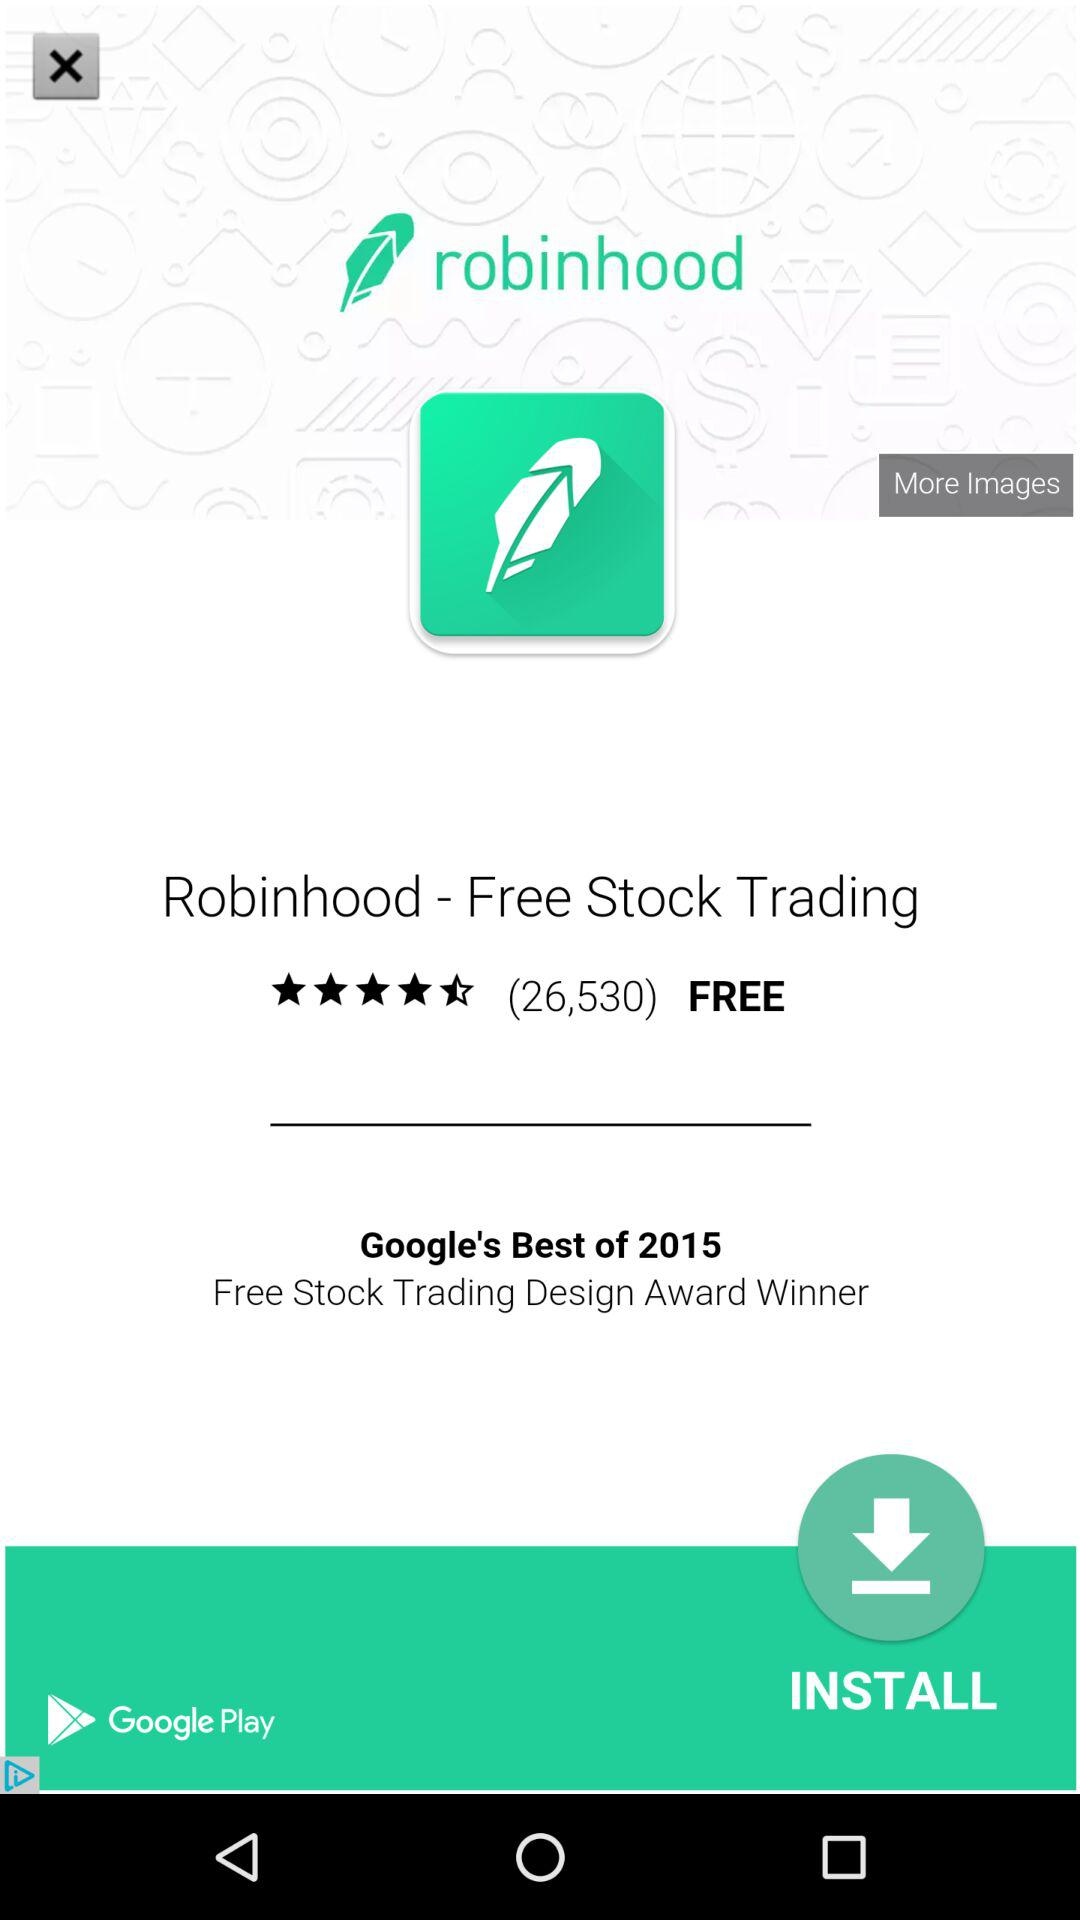How many downloads of the application?
When the provided information is insufficient, respond with <no answer>. <no answer> 